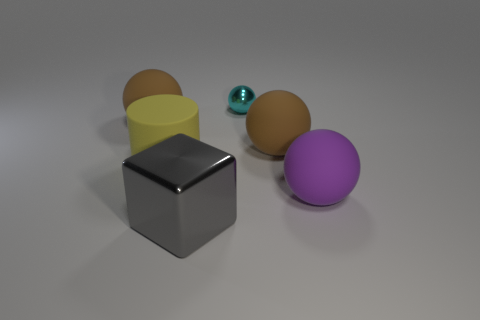Subtract all purple rubber spheres. How many spheres are left? 3 Add 2 large matte things. How many objects exist? 8 Subtract all cylinders. How many objects are left? 5 Add 4 gray objects. How many gray objects are left? 5 Add 5 green cylinders. How many green cylinders exist? 5 Subtract 1 cyan balls. How many objects are left? 5 Subtract all yellow spheres. Subtract all big gray shiny things. How many objects are left? 5 